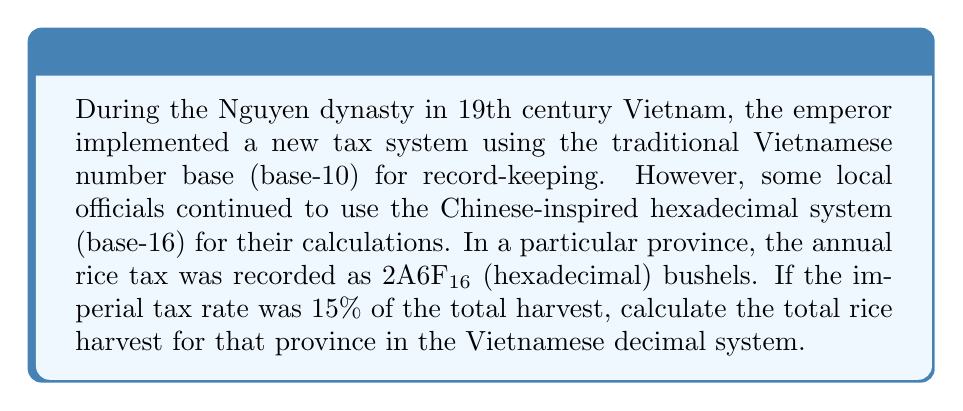Give your solution to this math problem. To solve this problem, we need to follow these steps:

1. Convert the hexadecimal number to decimal:
   $2A6F_{16} = 2 \times 16^3 + 10 \times 16^2 + 6 \times 16^1 + 15 \times 16^0$
   $= 2 \times 4096 + 10 \times 256 + 6 \times 16 + 15 \times 1$
   $= 8192 + 2560 + 96 + 15$
   $= 10863_{10}$

2. Since 10863 represents 15% of the total harvest, we need to calculate 100% of the harvest:
   Let $x$ be the total harvest.
   $15\% \text{ of } x = 10863$
   $0.15x = 10863$

3. Solve for $x$:
   $x = \frac{10863}{0.15} = 72420$

Therefore, the total rice harvest for the province in the Vietnamese decimal system is 72,420 bushels.
Answer: 72,420 bushels 